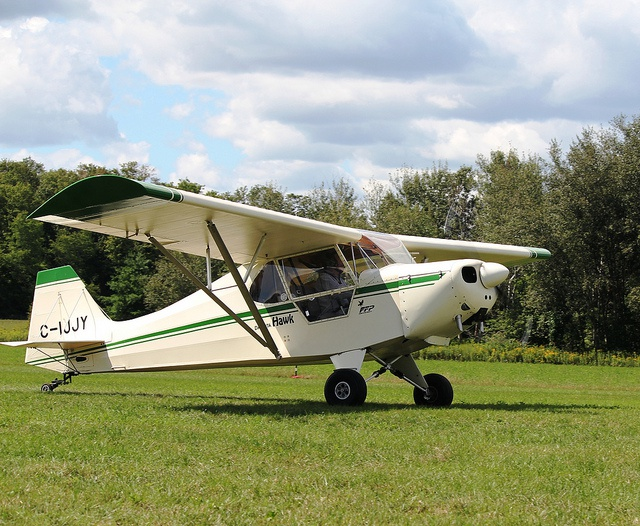Describe the objects in this image and their specific colors. I can see airplane in darkgray, ivory, black, and olive tones and people in darkgray, black, and gray tones in this image. 